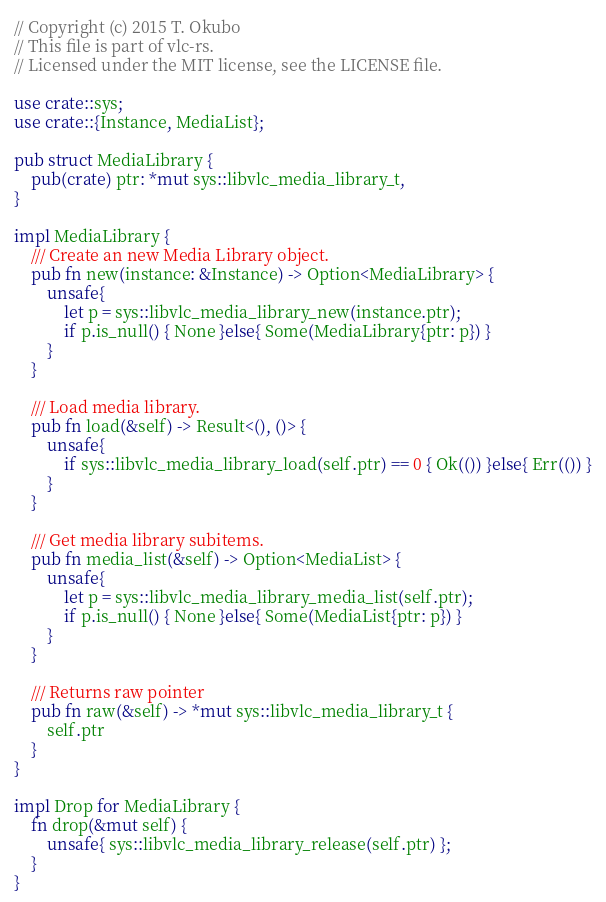<code> <loc_0><loc_0><loc_500><loc_500><_Rust_>// Copyright (c) 2015 T. Okubo
// This file is part of vlc-rs.
// Licensed under the MIT license, see the LICENSE file.

use crate::sys;
use crate::{Instance, MediaList};

pub struct MediaLibrary {
    pub(crate) ptr: *mut sys::libvlc_media_library_t,
}

impl MediaLibrary {
    /// Create an new Media Library object.
    pub fn new(instance: &Instance) -> Option<MediaLibrary> {
        unsafe{
            let p = sys::libvlc_media_library_new(instance.ptr);
            if p.is_null() { None }else{ Some(MediaLibrary{ptr: p}) }
        }
    }

    /// Load media library.
    pub fn load(&self) -> Result<(), ()> {
        unsafe{
            if sys::libvlc_media_library_load(self.ptr) == 0 { Ok(()) }else{ Err(()) }
        }
    }

    /// Get media library subitems.
    pub fn media_list(&self) -> Option<MediaList> {
        unsafe{
            let p = sys::libvlc_media_library_media_list(self.ptr);
            if p.is_null() { None }else{ Some(MediaList{ptr: p}) }
        }
    }

    /// Returns raw pointer
    pub fn raw(&self) -> *mut sys::libvlc_media_library_t {
        self.ptr
    }
}

impl Drop for MediaLibrary {
    fn drop(&mut self) {
        unsafe{ sys::libvlc_media_library_release(self.ptr) };
    }
}
</code> 